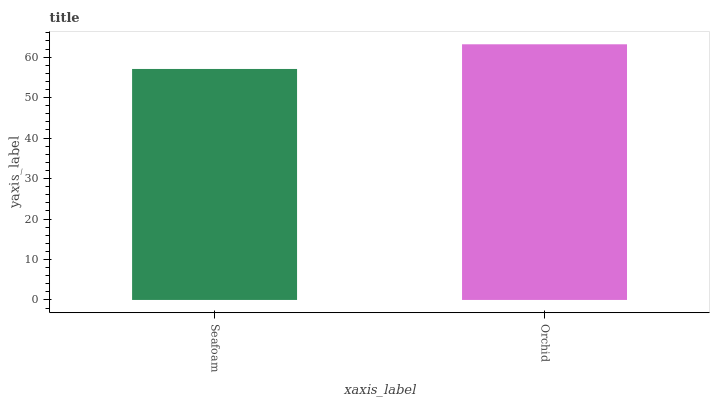Is Seafoam the minimum?
Answer yes or no. Yes. Is Orchid the maximum?
Answer yes or no. Yes. Is Orchid the minimum?
Answer yes or no. No. Is Orchid greater than Seafoam?
Answer yes or no. Yes. Is Seafoam less than Orchid?
Answer yes or no. Yes. Is Seafoam greater than Orchid?
Answer yes or no. No. Is Orchid less than Seafoam?
Answer yes or no. No. Is Orchid the high median?
Answer yes or no. Yes. Is Seafoam the low median?
Answer yes or no. Yes. Is Seafoam the high median?
Answer yes or no. No. Is Orchid the low median?
Answer yes or no. No. 